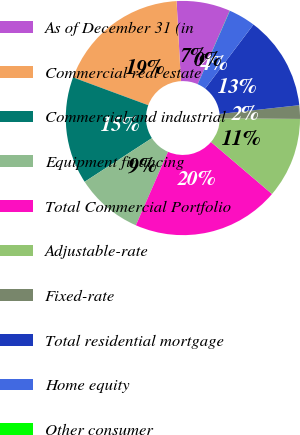Convert chart. <chart><loc_0><loc_0><loc_500><loc_500><pie_chart><fcel>As of December 31 (in<fcel>Commercial real estate<fcel>Commercial and industrial<fcel>Equipment financing<fcel>Total Commercial Portfolio<fcel>Adjustable-rate<fcel>Fixed-rate<fcel>Total residential mortgage<fcel>Home equity<fcel>Other consumer<nl><fcel>7.41%<fcel>18.5%<fcel>14.8%<fcel>9.26%<fcel>20.34%<fcel>11.11%<fcel>1.87%<fcel>12.96%<fcel>3.72%<fcel>0.02%<nl></chart> 